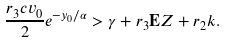Convert formula to latex. <formula><loc_0><loc_0><loc_500><loc_500>\frac { r _ { 3 } c v _ { 0 } } { 2 } e ^ { - y _ { 0 } / \alpha } > \gamma + r _ { 3 } { \mathbf E } Z + r _ { 2 } k .</formula> 